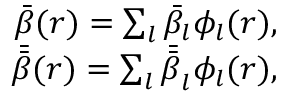<formula> <loc_0><loc_0><loc_500><loc_500>\begin{array} { r l } { \bar { \beta } ( r ) = \sum _ { l } \bar { \beta } _ { l } \phi _ { l } ( r ) , } \\ { \bar { \bar { \beta } } ( r ) = \sum _ { l } \bar { \bar { \beta } } _ { l } \phi _ { l } ( r ) , } \end{array}</formula> 